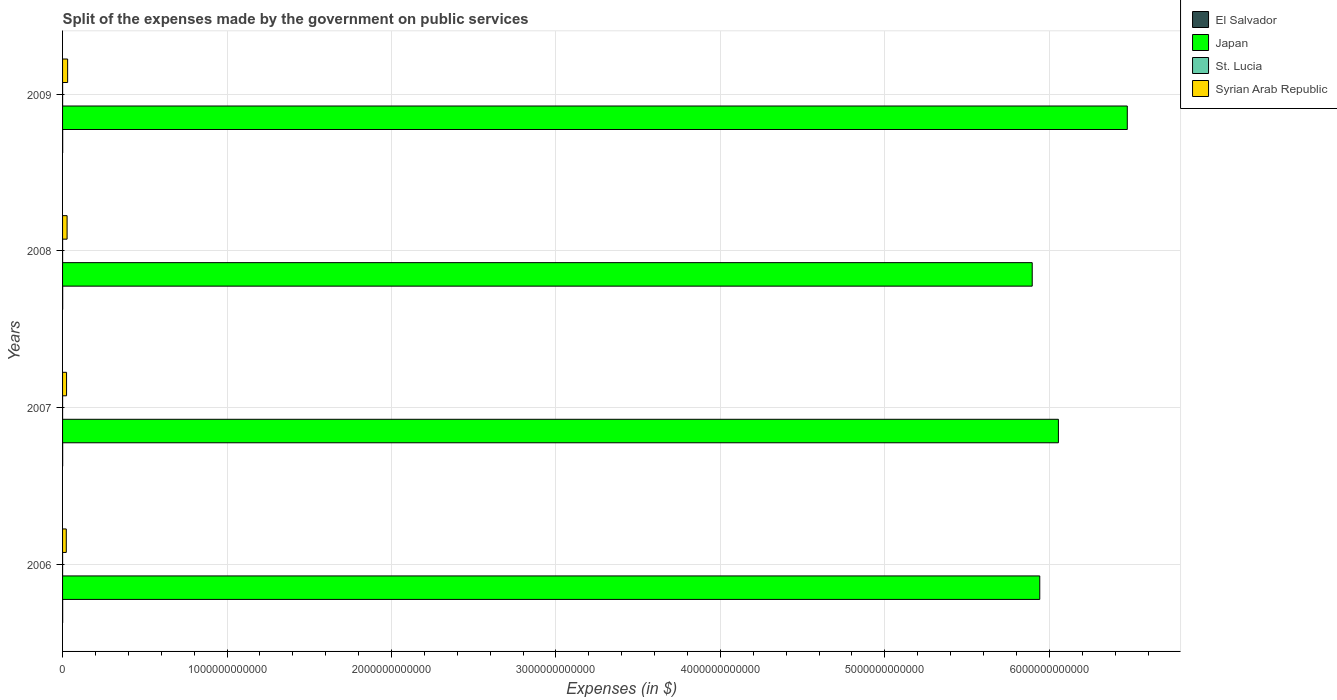How many groups of bars are there?
Give a very brief answer. 4. How many bars are there on the 2nd tick from the top?
Give a very brief answer. 4. What is the expenses made by the government on public services in El Salvador in 2006?
Offer a very short reply. 5.79e+08. Across all years, what is the maximum expenses made by the government on public services in El Salvador?
Offer a very short reply. 6.78e+08. Across all years, what is the minimum expenses made by the government on public services in El Salvador?
Make the answer very short. 5.53e+08. In which year was the expenses made by the government on public services in El Salvador maximum?
Give a very brief answer. 2009. What is the total expenses made by the government on public services in El Salvador in the graph?
Provide a short and direct response. 2.49e+09. What is the difference between the expenses made by the government on public services in Syrian Arab Republic in 2006 and that in 2007?
Your response must be concise. -1.78e+09. What is the difference between the expenses made by the government on public services in El Salvador in 2009 and the expenses made by the government on public services in Japan in 2007?
Your answer should be compact. -6.05e+12. What is the average expenses made by the government on public services in St. Lucia per year?
Provide a short and direct response. 1.19e+08. In the year 2008, what is the difference between the expenses made by the government on public services in St. Lucia and expenses made by the government on public services in Japan?
Give a very brief answer. -5.90e+12. What is the ratio of the expenses made by the government on public services in St. Lucia in 2006 to that in 2007?
Provide a succinct answer. 1.01. What is the difference between the highest and the second highest expenses made by the government on public services in Japan?
Offer a very short reply. 4.19e+11. What is the difference between the highest and the lowest expenses made by the government on public services in El Salvador?
Offer a very short reply. 1.25e+08. Is the sum of the expenses made by the government on public services in Japan in 2006 and 2007 greater than the maximum expenses made by the government on public services in Syrian Arab Republic across all years?
Give a very brief answer. Yes. What does the 4th bar from the top in 2006 represents?
Keep it short and to the point. El Salvador. What does the 3rd bar from the bottom in 2007 represents?
Give a very brief answer. St. Lucia. Is it the case that in every year, the sum of the expenses made by the government on public services in Japan and expenses made by the government on public services in St. Lucia is greater than the expenses made by the government on public services in Syrian Arab Republic?
Ensure brevity in your answer.  Yes. How many years are there in the graph?
Give a very brief answer. 4. What is the difference between two consecutive major ticks on the X-axis?
Ensure brevity in your answer.  1.00e+12. Does the graph contain grids?
Keep it short and to the point. Yes. How are the legend labels stacked?
Your answer should be compact. Vertical. What is the title of the graph?
Ensure brevity in your answer.  Split of the expenses made by the government on public services. What is the label or title of the X-axis?
Give a very brief answer. Expenses (in $). What is the Expenses (in $) of El Salvador in 2006?
Keep it short and to the point. 5.79e+08. What is the Expenses (in $) in Japan in 2006?
Make the answer very short. 5.94e+12. What is the Expenses (in $) in St. Lucia in 2006?
Your answer should be very brief. 1.04e+08. What is the Expenses (in $) of Syrian Arab Republic in 2006?
Keep it short and to the point. 2.25e+1. What is the Expenses (in $) in El Salvador in 2007?
Your answer should be compact. 5.53e+08. What is the Expenses (in $) of Japan in 2007?
Your response must be concise. 6.06e+12. What is the Expenses (in $) in St. Lucia in 2007?
Offer a very short reply. 1.04e+08. What is the Expenses (in $) of Syrian Arab Republic in 2007?
Your answer should be very brief. 2.43e+1. What is the Expenses (in $) in El Salvador in 2008?
Offer a very short reply. 6.76e+08. What is the Expenses (in $) of Japan in 2008?
Make the answer very short. 5.90e+12. What is the Expenses (in $) of St. Lucia in 2008?
Your response must be concise. 1.33e+08. What is the Expenses (in $) in Syrian Arab Republic in 2008?
Offer a terse response. 2.75e+1. What is the Expenses (in $) in El Salvador in 2009?
Your answer should be very brief. 6.78e+08. What is the Expenses (in $) of Japan in 2009?
Provide a succinct answer. 6.47e+12. What is the Expenses (in $) in St. Lucia in 2009?
Your answer should be very brief. 1.35e+08. What is the Expenses (in $) in Syrian Arab Republic in 2009?
Keep it short and to the point. 3.08e+1. Across all years, what is the maximum Expenses (in $) in El Salvador?
Your response must be concise. 6.78e+08. Across all years, what is the maximum Expenses (in $) of Japan?
Your response must be concise. 6.47e+12. Across all years, what is the maximum Expenses (in $) in St. Lucia?
Ensure brevity in your answer.  1.35e+08. Across all years, what is the maximum Expenses (in $) of Syrian Arab Republic?
Your answer should be compact. 3.08e+1. Across all years, what is the minimum Expenses (in $) in El Salvador?
Offer a terse response. 5.53e+08. Across all years, what is the minimum Expenses (in $) of Japan?
Ensure brevity in your answer.  5.90e+12. Across all years, what is the minimum Expenses (in $) of St. Lucia?
Your answer should be very brief. 1.04e+08. Across all years, what is the minimum Expenses (in $) in Syrian Arab Republic?
Provide a succinct answer. 2.25e+1. What is the total Expenses (in $) of El Salvador in the graph?
Offer a terse response. 2.49e+09. What is the total Expenses (in $) of Japan in the graph?
Ensure brevity in your answer.  2.44e+13. What is the total Expenses (in $) of St. Lucia in the graph?
Keep it short and to the point. 4.76e+08. What is the total Expenses (in $) in Syrian Arab Republic in the graph?
Your answer should be very brief. 1.05e+11. What is the difference between the Expenses (in $) of El Salvador in 2006 and that in 2007?
Provide a short and direct response. 2.62e+07. What is the difference between the Expenses (in $) of Japan in 2006 and that in 2007?
Ensure brevity in your answer.  -1.13e+11. What is the difference between the Expenses (in $) in St. Lucia in 2006 and that in 2007?
Offer a terse response. 8.00e+05. What is the difference between the Expenses (in $) in Syrian Arab Republic in 2006 and that in 2007?
Give a very brief answer. -1.78e+09. What is the difference between the Expenses (in $) of El Salvador in 2006 and that in 2008?
Offer a very short reply. -9.65e+07. What is the difference between the Expenses (in $) in Japan in 2006 and that in 2008?
Your answer should be very brief. 4.59e+1. What is the difference between the Expenses (in $) of St. Lucia in 2006 and that in 2008?
Keep it short and to the point. -2.88e+07. What is the difference between the Expenses (in $) of Syrian Arab Republic in 2006 and that in 2008?
Ensure brevity in your answer.  -4.96e+09. What is the difference between the Expenses (in $) of El Salvador in 2006 and that in 2009?
Offer a very short reply. -9.91e+07. What is the difference between the Expenses (in $) of Japan in 2006 and that in 2009?
Offer a very short reply. -5.32e+11. What is the difference between the Expenses (in $) in St. Lucia in 2006 and that in 2009?
Your answer should be very brief. -3.07e+07. What is the difference between the Expenses (in $) of Syrian Arab Republic in 2006 and that in 2009?
Your response must be concise. -8.30e+09. What is the difference between the Expenses (in $) in El Salvador in 2007 and that in 2008?
Your answer should be compact. -1.23e+08. What is the difference between the Expenses (in $) of Japan in 2007 and that in 2008?
Ensure brevity in your answer.  1.59e+11. What is the difference between the Expenses (in $) of St. Lucia in 2007 and that in 2008?
Your response must be concise. -2.96e+07. What is the difference between the Expenses (in $) in Syrian Arab Republic in 2007 and that in 2008?
Your answer should be compact. -3.19e+09. What is the difference between the Expenses (in $) in El Salvador in 2007 and that in 2009?
Give a very brief answer. -1.25e+08. What is the difference between the Expenses (in $) in Japan in 2007 and that in 2009?
Your answer should be very brief. -4.19e+11. What is the difference between the Expenses (in $) in St. Lucia in 2007 and that in 2009?
Offer a terse response. -3.15e+07. What is the difference between the Expenses (in $) in Syrian Arab Republic in 2007 and that in 2009?
Your response must be concise. -6.52e+09. What is the difference between the Expenses (in $) of El Salvador in 2008 and that in 2009?
Provide a succinct answer. -2.60e+06. What is the difference between the Expenses (in $) of Japan in 2008 and that in 2009?
Offer a terse response. -5.78e+11. What is the difference between the Expenses (in $) in St. Lucia in 2008 and that in 2009?
Your answer should be compact. -1.90e+06. What is the difference between the Expenses (in $) in Syrian Arab Republic in 2008 and that in 2009?
Keep it short and to the point. -3.34e+09. What is the difference between the Expenses (in $) of El Salvador in 2006 and the Expenses (in $) of Japan in 2007?
Provide a short and direct response. -6.05e+12. What is the difference between the Expenses (in $) of El Salvador in 2006 and the Expenses (in $) of St. Lucia in 2007?
Your answer should be very brief. 4.76e+08. What is the difference between the Expenses (in $) of El Salvador in 2006 and the Expenses (in $) of Syrian Arab Republic in 2007?
Provide a succinct answer. -2.37e+1. What is the difference between the Expenses (in $) of Japan in 2006 and the Expenses (in $) of St. Lucia in 2007?
Your answer should be very brief. 5.94e+12. What is the difference between the Expenses (in $) in Japan in 2006 and the Expenses (in $) in Syrian Arab Republic in 2007?
Offer a very short reply. 5.92e+12. What is the difference between the Expenses (in $) of St. Lucia in 2006 and the Expenses (in $) of Syrian Arab Republic in 2007?
Your answer should be very brief. -2.42e+1. What is the difference between the Expenses (in $) in El Salvador in 2006 and the Expenses (in $) in Japan in 2008?
Offer a terse response. -5.90e+12. What is the difference between the Expenses (in $) of El Salvador in 2006 and the Expenses (in $) of St. Lucia in 2008?
Provide a succinct answer. 4.46e+08. What is the difference between the Expenses (in $) of El Salvador in 2006 and the Expenses (in $) of Syrian Arab Republic in 2008?
Keep it short and to the point. -2.69e+1. What is the difference between the Expenses (in $) in Japan in 2006 and the Expenses (in $) in St. Lucia in 2008?
Your response must be concise. 5.94e+12. What is the difference between the Expenses (in $) in Japan in 2006 and the Expenses (in $) in Syrian Arab Republic in 2008?
Provide a succinct answer. 5.91e+12. What is the difference between the Expenses (in $) in St. Lucia in 2006 and the Expenses (in $) in Syrian Arab Republic in 2008?
Provide a short and direct response. -2.74e+1. What is the difference between the Expenses (in $) in El Salvador in 2006 and the Expenses (in $) in Japan in 2009?
Your answer should be very brief. -6.47e+12. What is the difference between the Expenses (in $) of El Salvador in 2006 and the Expenses (in $) of St. Lucia in 2009?
Keep it short and to the point. 4.44e+08. What is the difference between the Expenses (in $) of El Salvador in 2006 and the Expenses (in $) of Syrian Arab Republic in 2009?
Give a very brief answer. -3.03e+1. What is the difference between the Expenses (in $) of Japan in 2006 and the Expenses (in $) of St. Lucia in 2009?
Your response must be concise. 5.94e+12. What is the difference between the Expenses (in $) of Japan in 2006 and the Expenses (in $) of Syrian Arab Republic in 2009?
Provide a succinct answer. 5.91e+12. What is the difference between the Expenses (in $) of St. Lucia in 2006 and the Expenses (in $) of Syrian Arab Republic in 2009?
Offer a very short reply. -3.07e+1. What is the difference between the Expenses (in $) in El Salvador in 2007 and the Expenses (in $) in Japan in 2008?
Your answer should be very brief. -5.90e+12. What is the difference between the Expenses (in $) in El Salvador in 2007 and the Expenses (in $) in St. Lucia in 2008?
Keep it short and to the point. 4.20e+08. What is the difference between the Expenses (in $) in El Salvador in 2007 and the Expenses (in $) in Syrian Arab Republic in 2008?
Give a very brief answer. -2.70e+1. What is the difference between the Expenses (in $) of Japan in 2007 and the Expenses (in $) of St. Lucia in 2008?
Give a very brief answer. 6.06e+12. What is the difference between the Expenses (in $) of Japan in 2007 and the Expenses (in $) of Syrian Arab Republic in 2008?
Make the answer very short. 6.03e+12. What is the difference between the Expenses (in $) in St. Lucia in 2007 and the Expenses (in $) in Syrian Arab Republic in 2008?
Ensure brevity in your answer.  -2.74e+1. What is the difference between the Expenses (in $) of El Salvador in 2007 and the Expenses (in $) of Japan in 2009?
Your answer should be compact. -6.47e+12. What is the difference between the Expenses (in $) of El Salvador in 2007 and the Expenses (in $) of St. Lucia in 2009?
Your answer should be compact. 4.18e+08. What is the difference between the Expenses (in $) of El Salvador in 2007 and the Expenses (in $) of Syrian Arab Republic in 2009?
Provide a short and direct response. -3.03e+1. What is the difference between the Expenses (in $) in Japan in 2007 and the Expenses (in $) in St. Lucia in 2009?
Provide a succinct answer. 6.06e+12. What is the difference between the Expenses (in $) of Japan in 2007 and the Expenses (in $) of Syrian Arab Republic in 2009?
Your answer should be compact. 6.02e+12. What is the difference between the Expenses (in $) in St. Lucia in 2007 and the Expenses (in $) in Syrian Arab Republic in 2009?
Your answer should be compact. -3.07e+1. What is the difference between the Expenses (in $) in El Salvador in 2008 and the Expenses (in $) in Japan in 2009?
Provide a short and direct response. -6.47e+12. What is the difference between the Expenses (in $) of El Salvador in 2008 and the Expenses (in $) of St. Lucia in 2009?
Your answer should be very brief. 5.41e+08. What is the difference between the Expenses (in $) in El Salvador in 2008 and the Expenses (in $) in Syrian Arab Republic in 2009?
Give a very brief answer. -3.02e+1. What is the difference between the Expenses (in $) in Japan in 2008 and the Expenses (in $) in St. Lucia in 2009?
Ensure brevity in your answer.  5.90e+12. What is the difference between the Expenses (in $) in Japan in 2008 and the Expenses (in $) in Syrian Arab Republic in 2009?
Keep it short and to the point. 5.87e+12. What is the difference between the Expenses (in $) of St. Lucia in 2008 and the Expenses (in $) of Syrian Arab Republic in 2009?
Your answer should be compact. -3.07e+1. What is the average Expenses (in $) in El Salvador per year?
Give a very brief answer. 6.21e+08. What is the average Expenses (in $) in Japan per year?
Provide a short and direct response. 6.09e+12. What is the average Expenses (in $) in St. Lucia per year?
Provide a short and direct response. 1.19e+08. What is the average Expenses (in $) of Syrian Arab Republic per year?
Provide a succinct answer. 2.63e+1. In the year 2006, what is the difference between the Expenses (in $) in El Salvador and Expenses (in $) in Japan?
Keep it short and to the point. -5.94e+12. In the year 2006, what is the difference between the Expenses (in $) of El Salvador and Expenses (in $) of St. Lucia?
Offer a terse response. 4.75e+08. In the year 2006, what is the difference between the Expenses (in $) in El Salvador and Expenses (in $) in Syrian Arab Republic?
Offer a very short reply. -2.20e+1. In the year 2006, what is the difference between the Expenses (in $) of Japan and Expenses (in $) of St. Lucia?
Provide a succinct answer. 5.94e+12. In the year 2006, what is the difference between the Expenses (in $) in Japan and Expenses (in $) in Syrian Arab Republic?
Give a very brief answer. 5.92e+12. In the year 2006, what is the difference between the Expenses (in $) in St. Lucia and Expenses (in $) in Syrian Arab Republic?
Offer a terse response. -2.24e+1. In the year 2007, what is the difference between the Expenses (in $) in El Salvador and Expenses (in $) in Japan?
Ensure brevity in your answer.  -6.05e+12. In the year 2007, what is the difference between the Expenses (in $) of El Salvador and Expenses (in $) of St. Lucia?
Provide a short and direct response. 4.49e+08. In the year 2007, what is the difference between the Expenses (in $) in El Salvador and Expenses (in $) in Syrian Arab Republic?
Your answer should be compact. -2.38e+1. In the year 2007, what is the difference between the Expenses (in $) of Japan and Expenses (in $) of St. Lucia?
Give a very brief answer. 6.06e+12. In the year 2007, what is the difference between the Expenses (in $) of Japan and Expenses (in $) of Syrian Arab Republic?
Offer a very short reply. 6.03e+12. In the year 2007, what is the difference between the Expenses (in $) of St. Lucia and Expenses (in $) of Syrian Arab Republic?
Ensure brevity in your answer.  -2.42e+1. In the year 2008, what is the difference between the Expenses (in $) in El Salvador and Expenses (in $) in Japan?
Your response must be concise. -5.90e+12. In the year 2008, what is the difference between the Expenses (in $) of El Salvador and Expenses (in $) of St. Lucia?
Offer a terse response. 5.42e+08. In the year 2008, what is the difference between the Expenses (in $) of El Salvador and Expenses (in $) of Syrian Arab Republic?
Provide a short and direct response. -2.68e+1. In the year 2008, what is the difference between the Expenses (in $) in Japan and Expenses (in $) in St. Lucia?
Ensure brevity in your answer.  5.90e+12. In the year 2008, what is the difference between the Expenses (in $) in Japan and Expenses (in $) in Syrian Arab Republic?
Your answer should be compact. 5.87e+12. In the year 2008, what is the difference between the Expenses (in $) of St. Lucia and Expenses (in $) of Syrian Arab Republic?
Your response must be concise. -2.74e+1. In the year 2009, what is the difference between the Expenses (in $) in El Salvador and Expenses (in $) in Japan?
Your response must be concise. -6.47e+12. In the year 2009, what is the difference between the Expenses (in $) of El Salvador and Expenses (in $) of St. Lucia?
Make the answer very short. 5.43e+08. In the year 2009, what is the difference between the Expenses (in $) of El Salvador and Expenses (in $) of Syrian Arab Republic?
Provide a succinct answer. -3.02e+1. In the year 2009, what is the difference between the Expenses (in $) of Japan and Expenses (in $) of St. Lucia?
Give a very brief answer. 6.47e+12. In the year 2009, what is the difference between the Expenses (in $) of Japan and Expenses (in $) of Syrian Arab Republic?
Keep it short and to the point. 6.44e+12. In the year 2009, what is the difference between the Expenses (in $) in St. Lucia and Expenses (in $) in Syrian Arab Republic?
Keep it short and to the point. -3.07e+1. What is the ratio of the Expenses (in $) of El Salvador in 2006 to that in 2007?
Your answer should be very brief. 1.05. What is the ratio of the Expenses (in $) in Japan in 2006 to that in 2007?
Offer a terse response. 0.98. What is the ratio of the Expenses (in $) in St. Lucia in 2006 to that in 2007?
Give a very brief answer. 1.01. What is the ratio of the Expenses (in $) of Syrian Arab Republic in 2006 to that in 2007?
Your response must be concise. 0.93. What is the ratio of the Expenses (in $) of El Salvador in 2006 to that in 2008?
Your answer should be compact. 0.86. What is the ratio of the Expenses (in $) in St. Lucia in 2006 to that in 2008?
Your answer should be very brief. 0.78. What is the ratio of the Expenses (in $) in Syrian Arab Republic in 2006 to that in 2008?
Provide a short and direct response. 0.82. What is the ratio of the Expenses (in $) in El Salvador in 2006 to that in 2009?
Ensure brevity in your answer.  0.85. What is the ratio of the Expenses (in $) in Japan in 2006 to that in 2009?
Your response must be concise. 0.92. What is the ratio of the Expenses (in $) of St. Lucia in 2006 to that in 2009?
Provide a short and direct response. 0.77. What is the ratio of the Expenses (in $) in Syrian Arab Republic in 2006 to that in 2009?
Provide a succinct answer. 0.73. What is the ratio of the Expenses (in $) in El Salvador in 2007 to that in 2008?
Your answer should be compact. 0.82. What is the ratio of the Expenses (in $) in Japan in 2007 to that in 2008?
Make the answer very short. 1.03. What is the ratio of the Expenses (in $) in St. Lucia in 2007 to that in 2008?
Provide a succinct answer. 0.78. What is the ratio of the Expenses (in $) of Syrian Arab Republic in 2007 to that in 2008?
Your response must be concise. 0.88. What is the ratio of the Expenses (in $) in El Salvador in 2007 to that in 2009?
Ensure brevity in your answer.  0.82. What is the ratio of the Expenses (in $) in Japan in 2007 to that in 2009?
Make the answer very short. 0.94. What is the ratio of the Expenses (in $) in St. Lucia in 2007 to that in 2009?
Provide a short and direct response. 0.77. What is the ratio of the Expenses (in $) of Syrian Arab Republic in 2007 to that in 2009?
Ensure brevity in your answer.  0.79. What is the ratio of the Expenses (in $) of El Salvador in 2008 to that in 2009?
Ensure brevity in your answer.  1. What is the ratio of the Expenses (in $) in Japan in 2008 to that in 2009?
Provide a short and direct response. 0.91. What is the ratio of the Expenses (in $) of St. Lucia in 2008 to that in 2009?
Your response must be concise. 0.99. What is the ratio of the Expenses (in $) in Syrian Arab Republic in 2008 to that in 2009?
Your response must be concise. 0.89. What is the difference between the highest and the second highest Expenses (in $) in El Salvador?
Ensure brevity in your answer.  2.60e+06. What is the difference between the highest and the second highest Expenses (in $) in Japan?
Ensure brevity in your answer.  4.19e+11. What is the difference between the highest and the second highest Expenses (in $) of St. Lucia?
Offer a very short reply. 1.90e+06. What is the difference between the highest and the second highest Expenses (in $) in Syrian Arab Republic?
Provide a short and direct response. 3.34e+09. What is the difference between the highest and the lowest Expenses (in $) in El Salvador?
Keep it short and to the point. 1.25e+08. What is the difference between the highest and the lowest Expenses (in $) in Japan?
Provide a succinct answer. 5.78e+11. What is the difference between the highest and the lowest Expenses (in $) of St. Lucia?
Your answer should be compact. 3.15e+07. What is the difference between the highest and the lowest Expenses (in $) in Syrian Arab Republic?
Your response must be concise. 8.30e+09. 